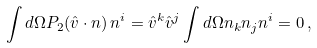<formula> <loc_0><loc_0><loc_500><loc_500>\int d \Omega P _ { 2 } ( { \hat { v } } \cdot { n } ) \, n ^ { i } = { \hat { v } } ^ { k } { \hat { v } } ^ { j } \int d \Omega n _ { k } n _ { j } n ^ { i } = 0 \, ,</formula> 